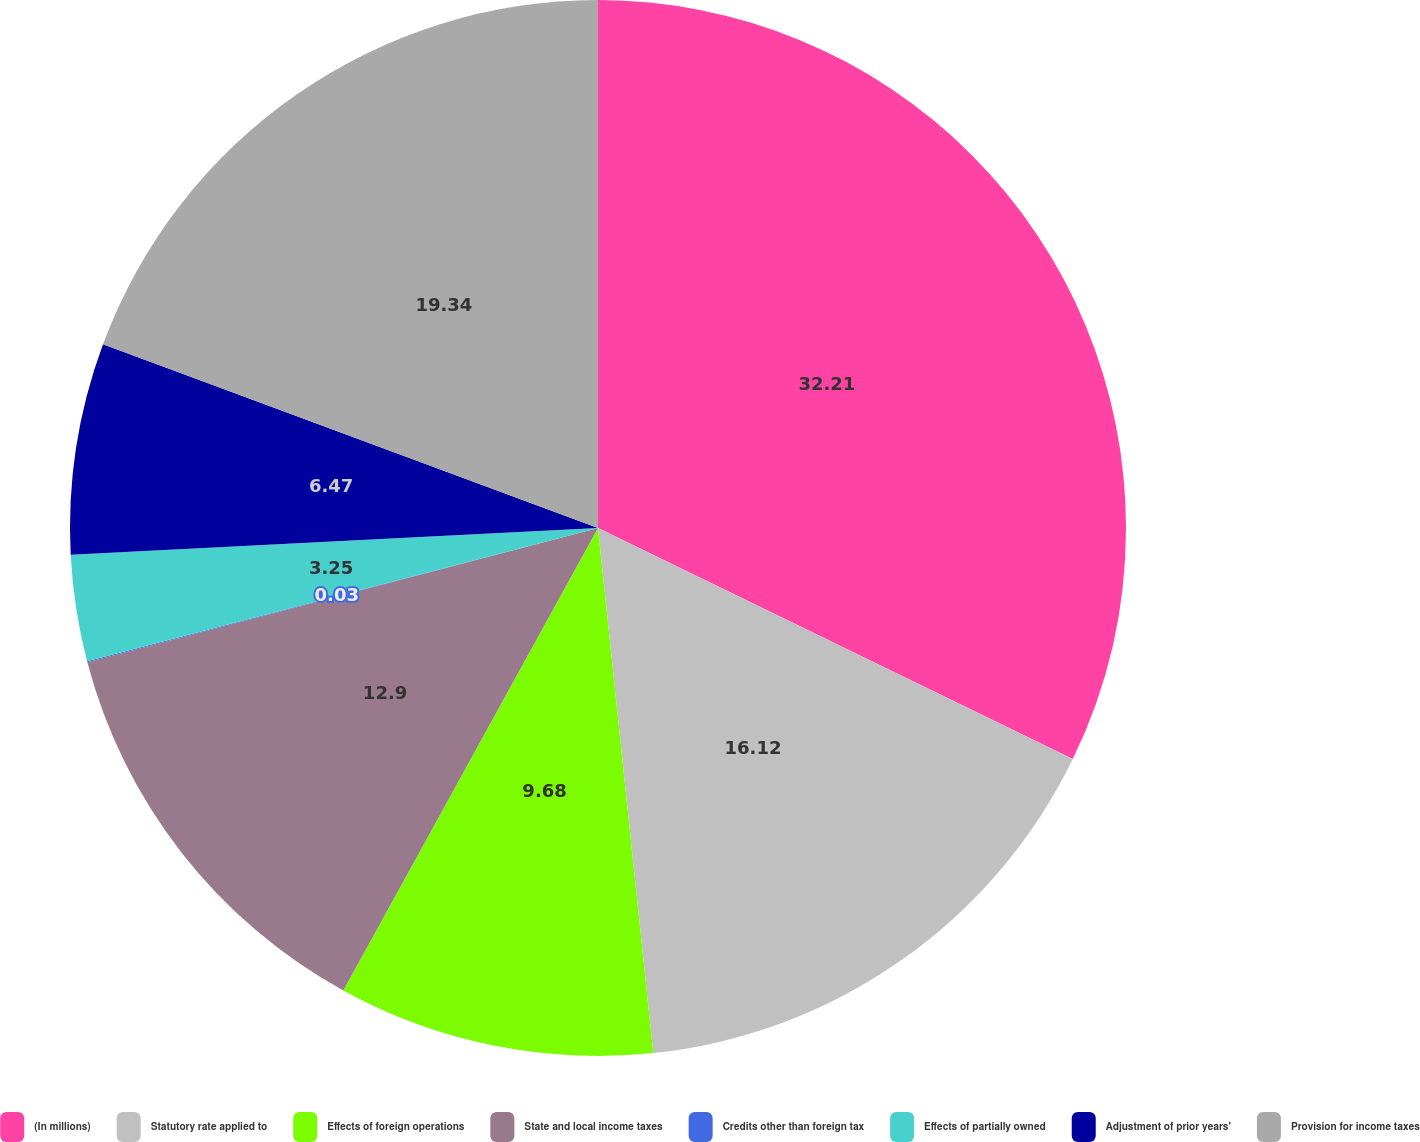<chart> <loc_0><loc_0><loc_500><loc_500><pie_chart><fcel>(In millions)<fcel>Statutory rate applied to<fcel>Effects of foreign operations<fcel>State and local income taxes<fcel>Credits other than foreign tax<fcel>Effects of partially owned<fcel>Adjustment of prior years'<fcel>Provision for income taxes<nl><fcel>32.21%<fcel>16.12%<fcel>9.68%<fcel>12.9%<fcel>0.03%<fcel>3.25%<fcel>6.47%<fcel>19.34%<nl></chart> 